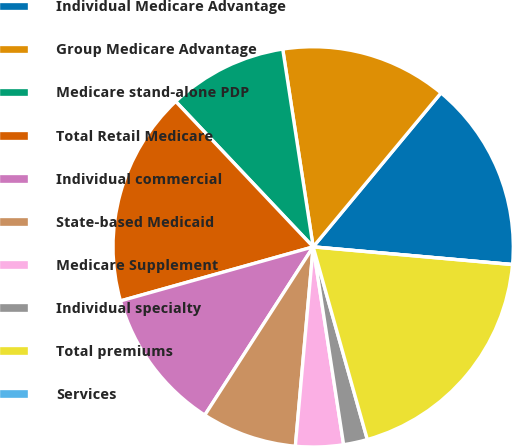Convert chart. <chart><loc_0><loc_0><loc_500><loc_500><pie_chart><fcel>Individual Medicare Advantage<fcel>Group Medicare Advantage<fcel>Medicare stand-alone PDP<fcel>Total Retail Medicare<fcel>Individual commercial<fcel>State-based Medicaid<fcel>Medicare Supplement<fcel>Individual specialty<fcel>Total premiums<fcel>Services<nl><fcel>15.38%<fcel>13.46%<fcel>9.62%<fcel>17.3%<fcel>11.54%<fcel>7.69%<fcel>3.85%<fcel>1.93%<fcel>19.23%<fcel>0.0%<nl></chart> 